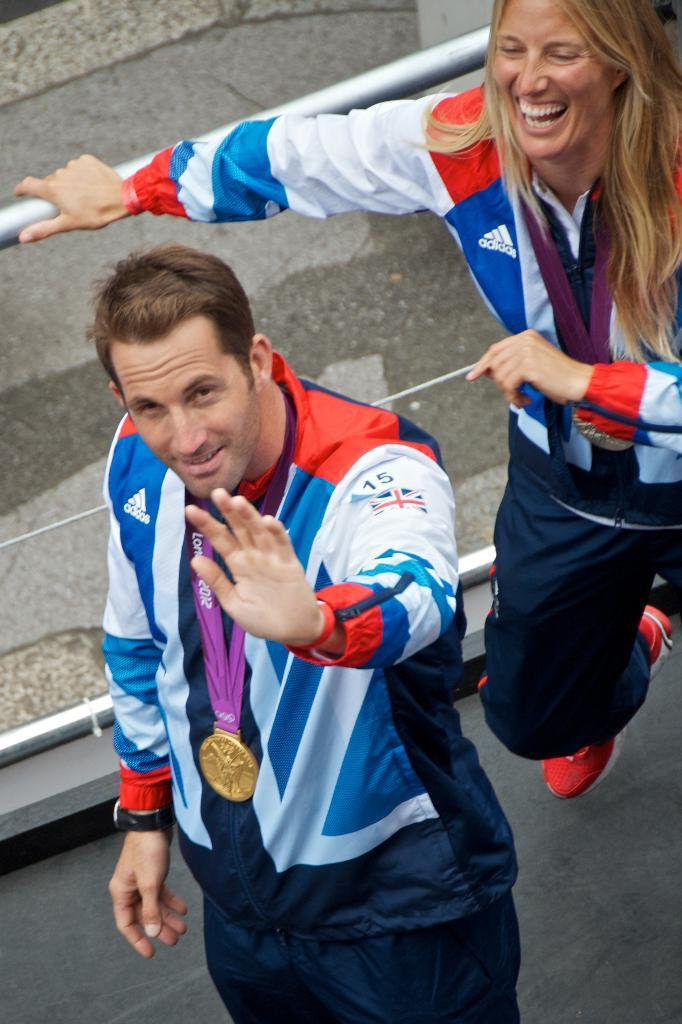What is the main subject in the foreground of the image? There is a man in the foreground of the image. What is the man wearing? The man is wearing a jacket. Does the man have any notable accessory or achievement? Yes, the man has a medal. Who else is present in the image? There is a woman in the image. What is the woman wearing? The woman is wearing a jacket. What is the woman's position in relation to the railing? The woman is standing near a railing. What type of surface is visible at the top of the image? There is a pavement at the top of the image. Can you tell me how many rats are visible on the pavement in the image? There are no rats visible on the pavement in the image. What type of government is depicted in the image? There is no depiction of a government in the image. 